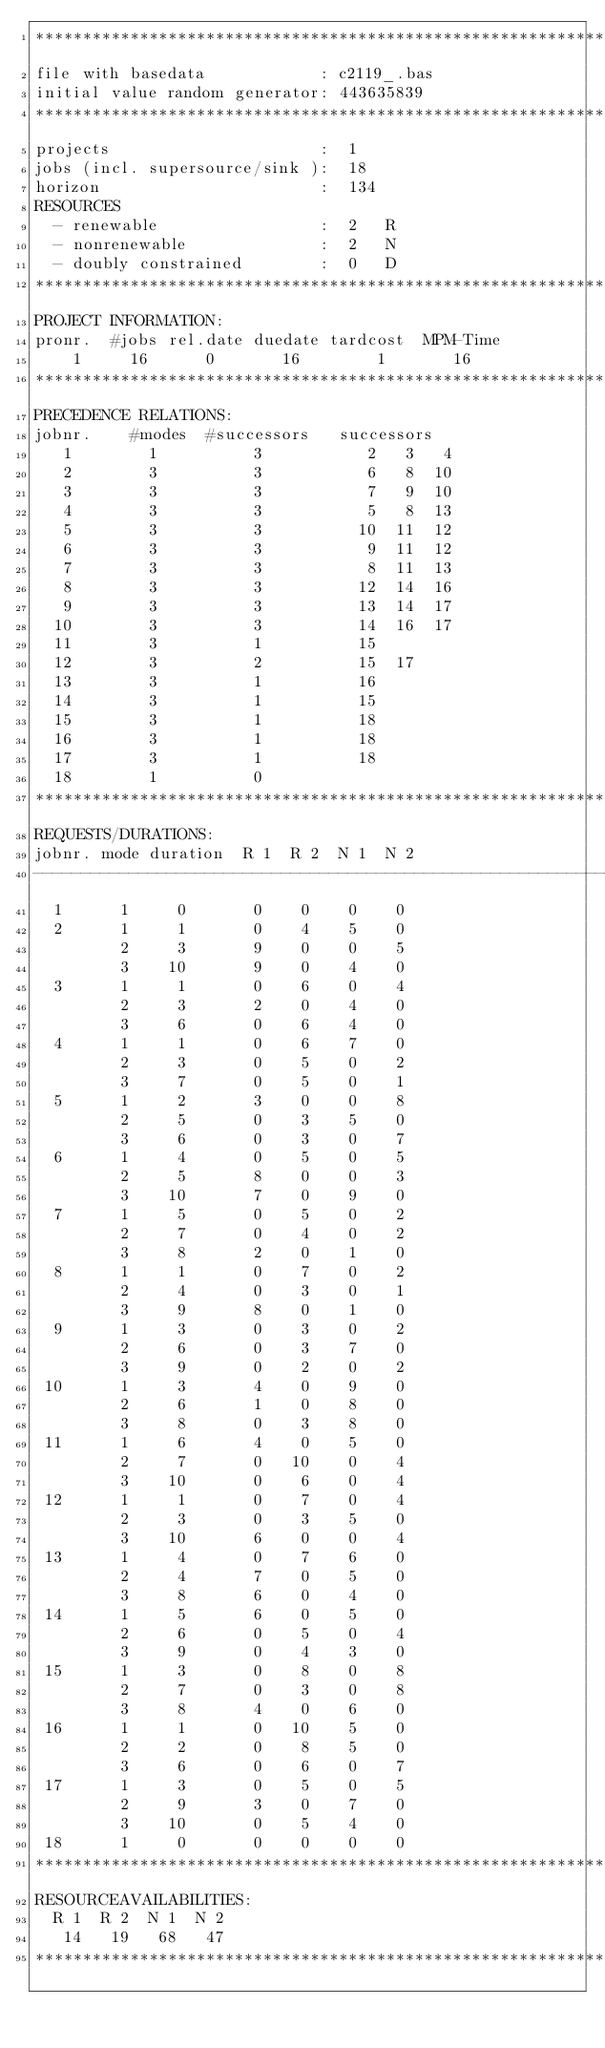Convert code to text. <code><loc_0><loc_0><loc_500><loc_500><_ObjectiveC_>************************************************************************
file with basedata            : c2119_.bas
initial value random generator: 443635839
************************************************************************
projects                      :  1
jobs (incl. supersource/sink ):  18
horizon                       :  134
RESOURCES
  - renewable                 :  2   R
  - nonrenewable              :  2   N
  - doubly constrained        :  0   D
************************************************************************
PROJECT INFORMATION:
pronr.  #jobs rel.date duedate tardcost  MPM-Time
    1     16      0       16        1       16
************************************************************************
PRECEDENCE RELATIONS:
jobnr.    #modes  #successors   successors
   1        1          3           2   3   4
   2        3          3           6   8  10
   3        3          3           7   9  10
   4        3          3           5   8  13
   5        3          3          10  11  12
   6        3          3           9  11  12
   7        3          3           8  11  13
   8        3          3          12  14  16
   9        3          3          13  14  17
  10        3          3          14  16  17
  11        3          1          15
  12        3          2          15  17
  13        3          1          16
  14        3          1          15
  15        3          1          18
  16        3          1          18
  17        3          1          18
  18        1          0        
************************************************************************
REQUESTS/DURATIONS:
jobnr. mode duration  R 1  R 2  N 1  N 2
------------------------------------------------------------------------
  1      1     0       0    0    0    0
  2      1     1       0    4    5    0
         2     3       9    0    0    5
         3    10       9    0    4    0
  3      1     1       0    6    0    4
         2     3       2    0    4    0
         3     6       0    6    4    0
  4      1     1       0    6    7    0
         2     3       0    5    0    2
         3     7       0    5    0    1
  5      1     2       3    0    0    8
         2     5       0    3    5    0
         3     6       0    3    0    7
  6      1     4       0    5    0    5
         2     5       8    0    0    3
         3    10       7    0    9    0
  7      1     5       0    5    0    2
         2     7       0    4    0    2
         3     8       2    0    1    0
  8      1     1       0    7    0    2
         2     4       0    3    0    1
         3     9       8    0    1    0
  9      1     3       0    3    0    2
         2     6       0    3    7    0
         3     9       0    2    0    2
 10      1     3       4    0    9    0
         2     6       1    0    8    0
         3     8       0    3    8    0
 11      1     6       4    0    5    0
         2     7       0   10    0    4
         3    10       0    6    0    4
 12      1     1       0    7    0    4
         2     3       0    3    5    0
         3    10       6    0    0    4
 13      1     4       0    7    6    0
         2     4       7    0    5    0
         3     8       6    0    4    0
 14      1     5       6    0    5    0
         2     6       0    5    0    4
         3     9       0    4    3    0
 15      1     3       0    8    0    8
         2     7       0    3    0    8
         3     8       4    0    6    0
 16      1     1       0   10    5    0
         2     2       0    8    5    0
         3     6       0    6    0    7
 17      1     3       0    5    0    5
         2     9       3    0    7    0
         3    10       0    5    4    0
 18      1     0       0    0    0    0
************************************************************************
RESOURCEAVAILABILITIES:
  R 1  R 2  N 1  N 2
   14   19   68   47
************************************************************************
</code> 